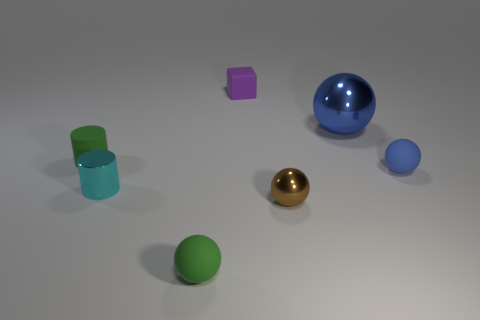What shape is the other thing that is the same color as the large object?
Provide a succinct answer. Sphere. The other rubber ball that is the same color as the big sphere is what size?
Keep it short and to the point. Small. How many other brown things are the same material as the large thing?
Make the answer very short. 1. What number of purple rubber things have the same size as the metallic cylinder?
Make the answer very short. 1. There is a blue ball that is behind the green object left of the matte sphere to the left of the small blue object; what is it made of?
Provide a short and direct response. Metal. How many objects are either big matte objects or tiny purple things?
Give a very brief answer. 1. Is there anything else that is the same material as the tiny green ball?
Offer a very short reply. Yes. The big thing is what shape?
Provide a short and direct response. Sphere. The green object in front of the tiny shiny thing that is to the right of the tiny shiny cylinder is what shape?
Your answer should be compact. Sphere. Do the small cylinder behind the cyan cylinder and the cube have the same material?
Give a very brief answer. Yes. 